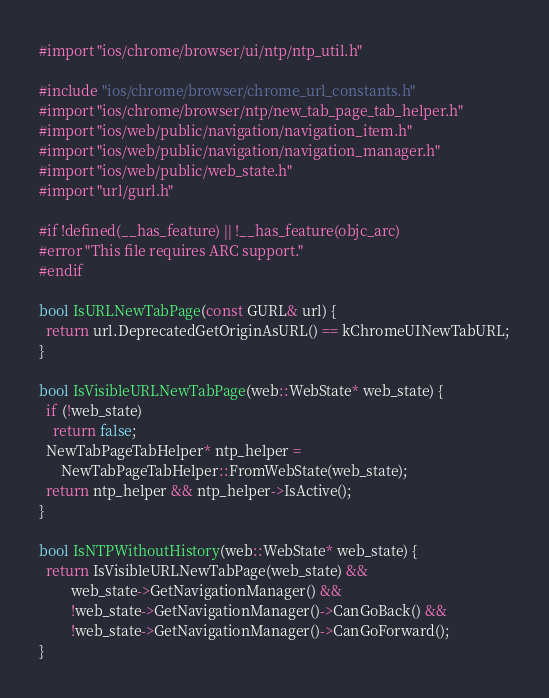<code> <loc_0><loc_0><loc_500><loc_500><_ObjectiveC_>#import "ios/chrome/browser/ui/ntp/ntp_util.h"

#include "ios/chrome/browser/chrome_url_constants.h"
#import "ios/chrome/browser/ntp/new_tab_page_tab_helper.h"
#import "ios/web/public/navigation/navigation_item.h"
#import "ios/web/public/navigation/navigation_manager.h"
#import "ios/web/public/web_state.h"
#import "url/gurl.h"

#if !defined(__has_feature) || !__has_feature(objc_arc)
#error "This file requires ARC support."
#endif

bool IsURLNewTabPage(const GURL& url) {
  return url.DeprecatedGetOriginAsURL() == kChromeUINewTabURL;
}

bool IsVisibleURLNewTabPage(web::WebState* web_state) {
  if (!web_state)
    return false;
  NewTabPageTabHelper* ntp_helper =
      NewTabPageTabHelper::FromWebState(web_state);
  return ntp_helper && ntp_helper->IsActive();
}

bool IsNTPWithoutHistory(web::WebState* web_state) {
  return IsVisibleURLNewTabPage(web_state) &&
         web_state->GetNavigationManager() &&
         !web_state->GetNavigationManager()->CanGoBack() &&
         !web_state->GetNavigationManager()->CanGoForward();
}
</code> 